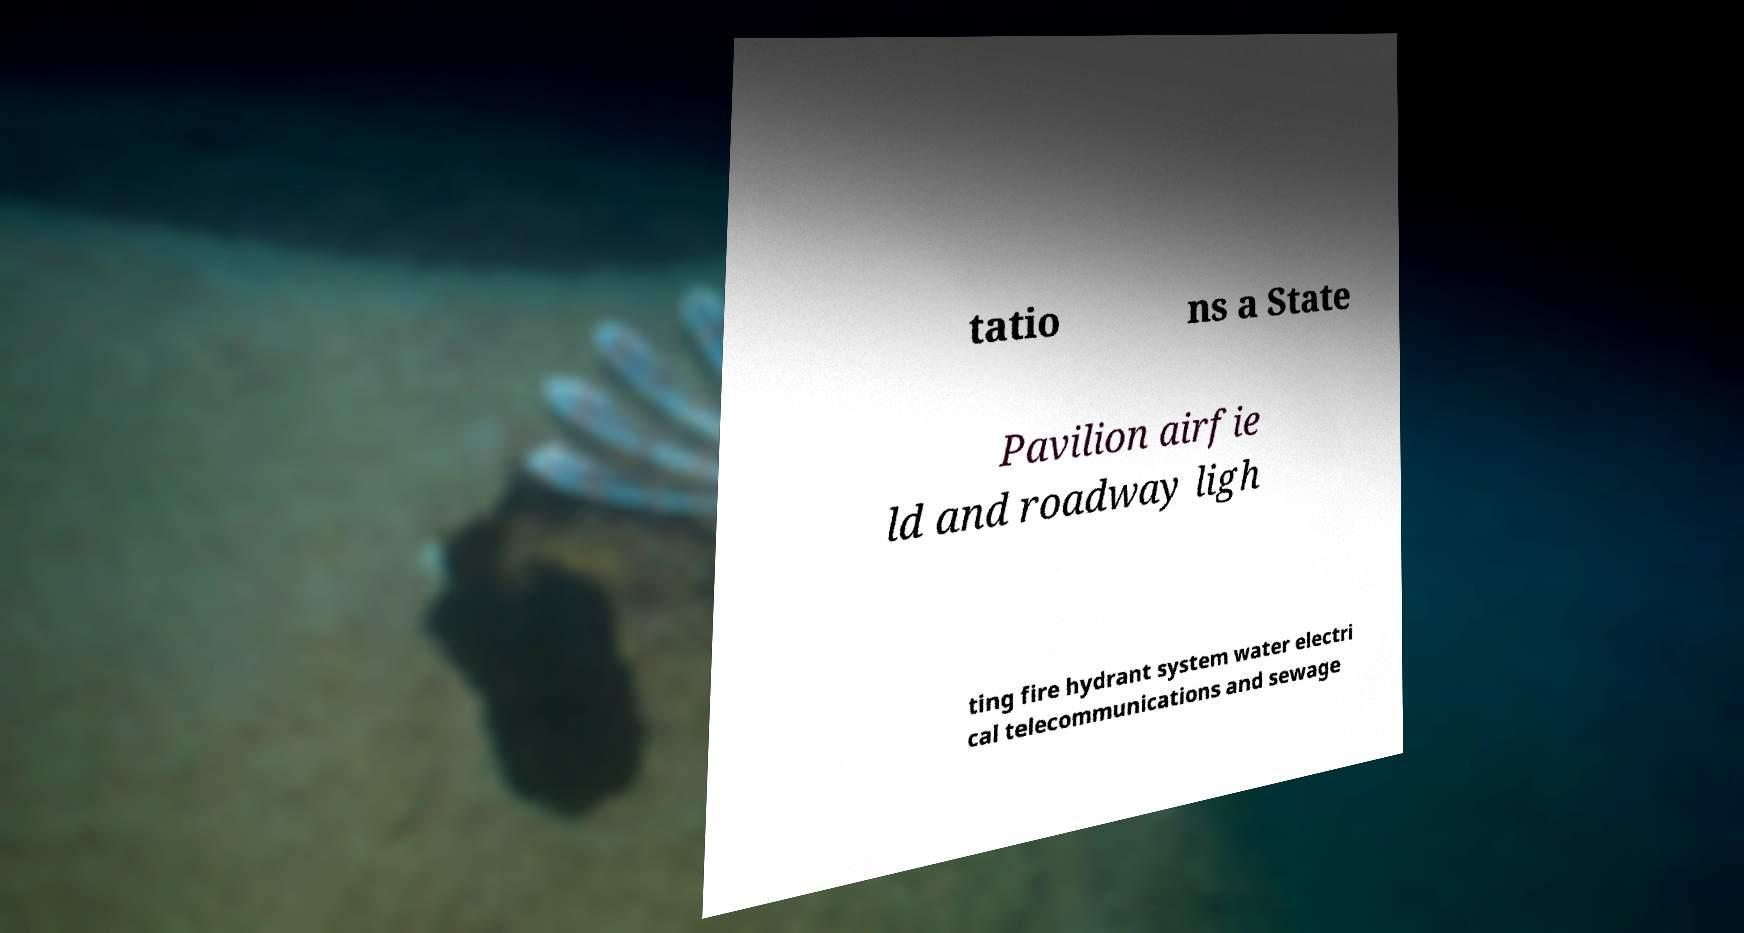Could you assist in decoding the text presented in this image and type it out clearly? tatio ns a State Pavilion airfie ld and roadway ligh ting fire hydrant system water electri cal telecommunications and sewage 